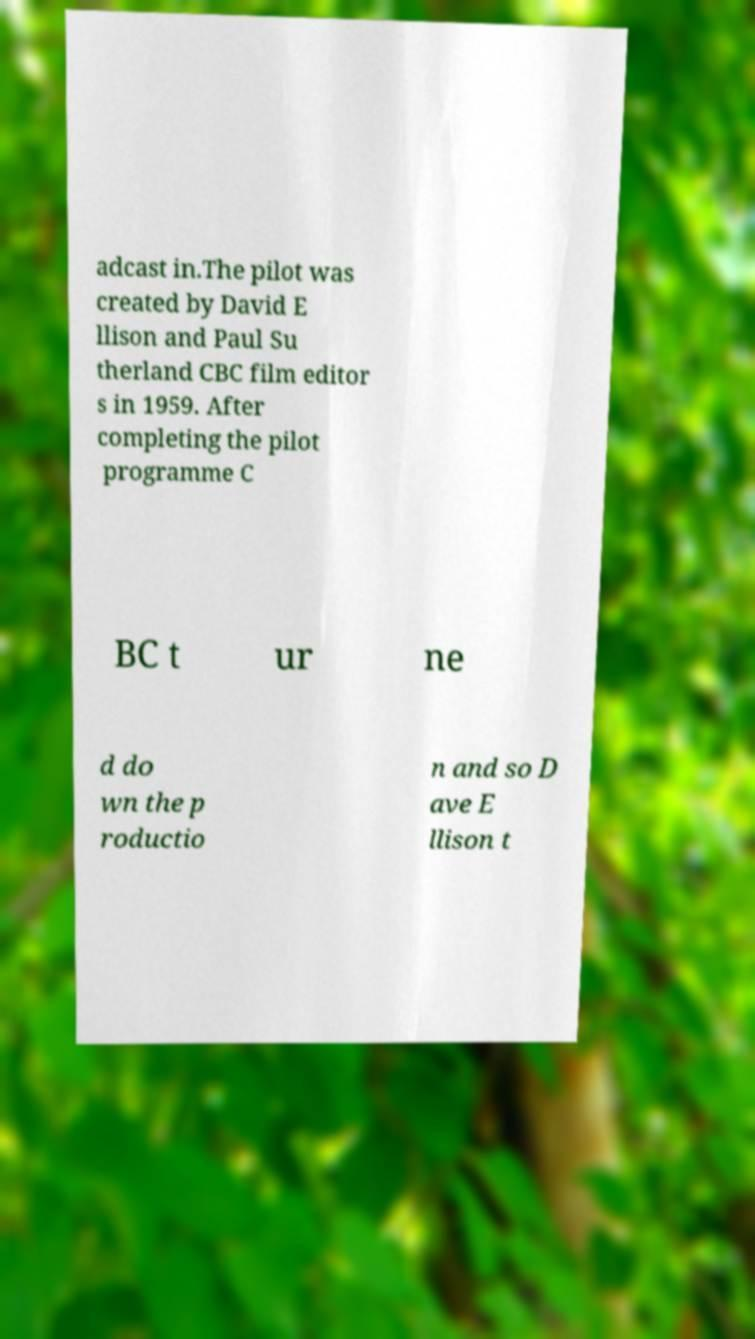There's text embedded in this image that I need extracted. Can you transcribe it verbatim? adcast in.The pilot was created by David E llison and Paul Su therland CBC film editor s in 1959. After completing the pilot programme C BC t ur ne d do wn the p roductio n and so D ave E llison t 